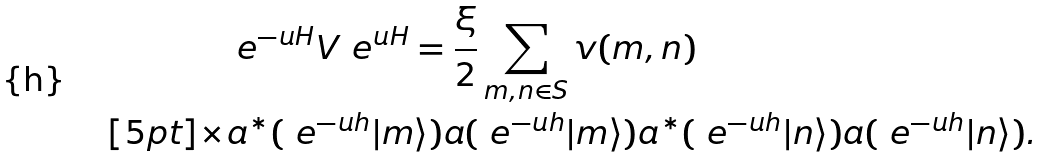<formula> <loc_0><loc_0><loc_500><loc_500>& \ e ^ { - \i u H } V \ e ^ { \i u H } = \frac { \xi } { 2 } \sum _ { m , n \in S } v ( m , n ) \\ [ 5 p t ] \times & a ^ { \ast } ( \ e ^ { - \i u h } | m \rangle ) a ( \ e ^ { - \i u h } | m \rangle ) a ^ { \ast } ( \ e ^ { - \i u h } | n \rangle ) a ( \ e ^ { - \i u h } | n \rangle ) .</formula> 